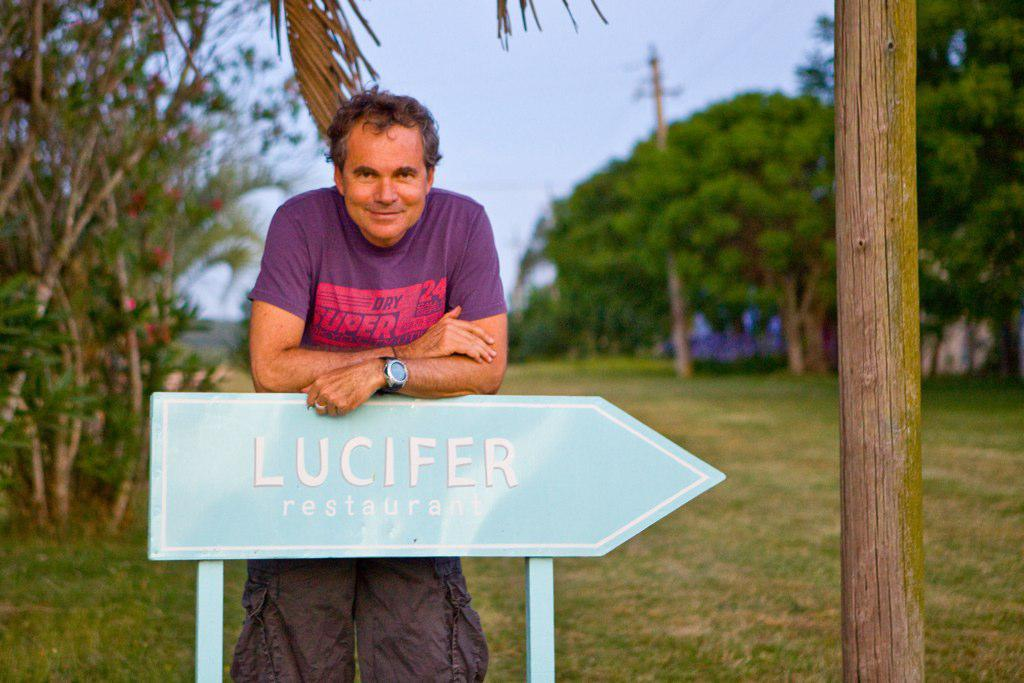What is located in the foreground of the image? There is a man and a sign board in the foreground of the image. What can be seen on the right side of the image? There is a bamboo on the right side of the image. What type of vegetation is visible in the background of the image? There are trees and grassland in the background of the image. What other objects can be seen in the background of the image? There is a pole and the sky is visible in the background of the image. Can you tell me how many thumbs the man has in the image? There is no information about the man's thumbs in the image, so it cannot be determined. What type of mark can be seen on the sign board in the image? There is no mention of any mark on the sign board in the image. 